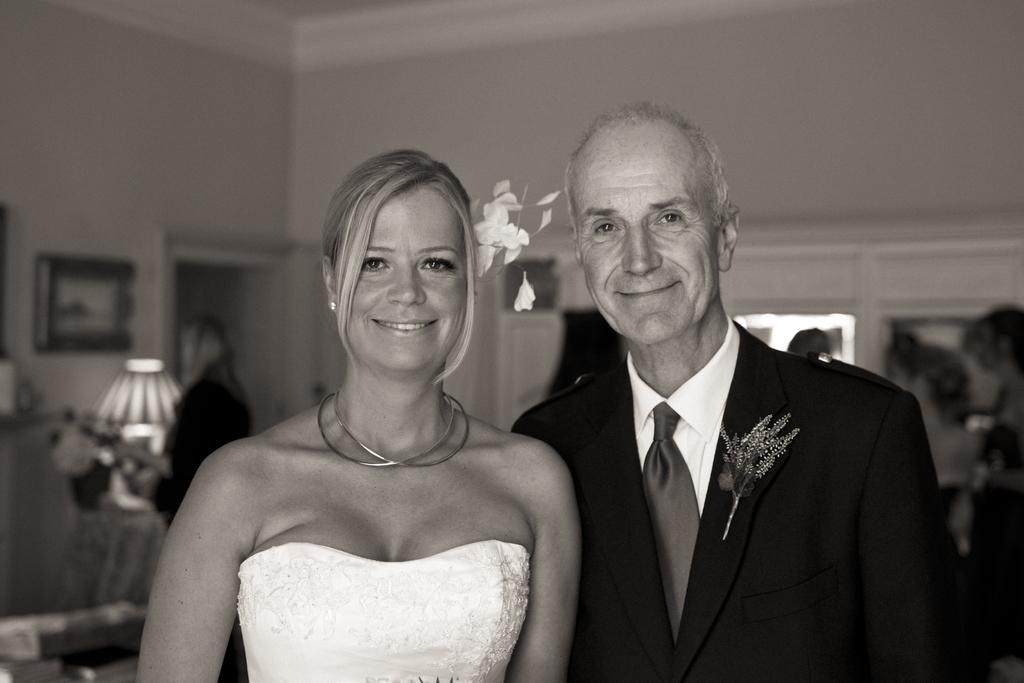Can you describe this image briefly? In this picture there are people standing and smiling. In the background of the image it is blurry and we can see people, wall and objects. 